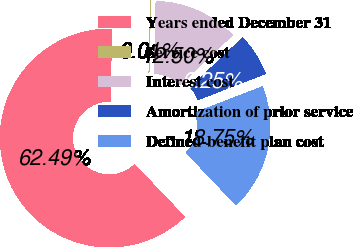Convert chart to OTSL. <chart><loc_0><loc_0><loc_500><loc_500><pie_chart><fcel>Years ended December 31<fcel>Service cost<fcel>Interest cost<fcel>Amortization of prior service<fcel>Defined-benefit plan cost<nl><fcel>62.49%<fcel>0.01%<fcel>12.5%<fcel>6.25%<fcel>18.75%<nl></chart> 